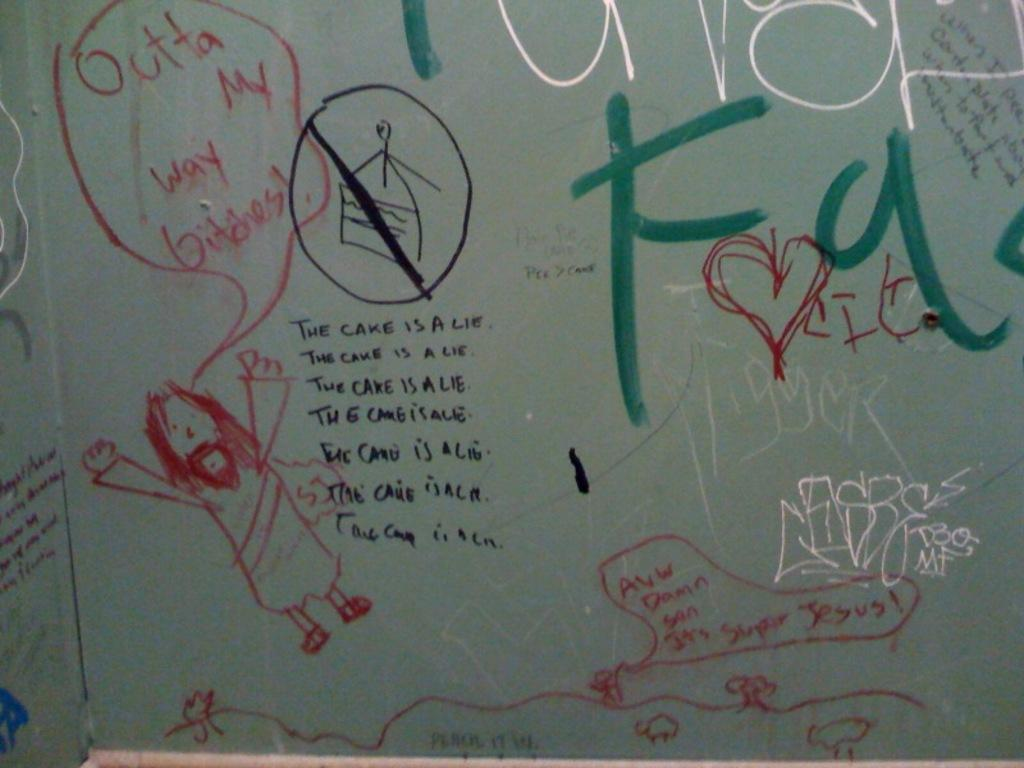<image>
Give a short and clear explanation of the subsequent image. A bunch of graffiti with one of them saying the cake is a lie. 